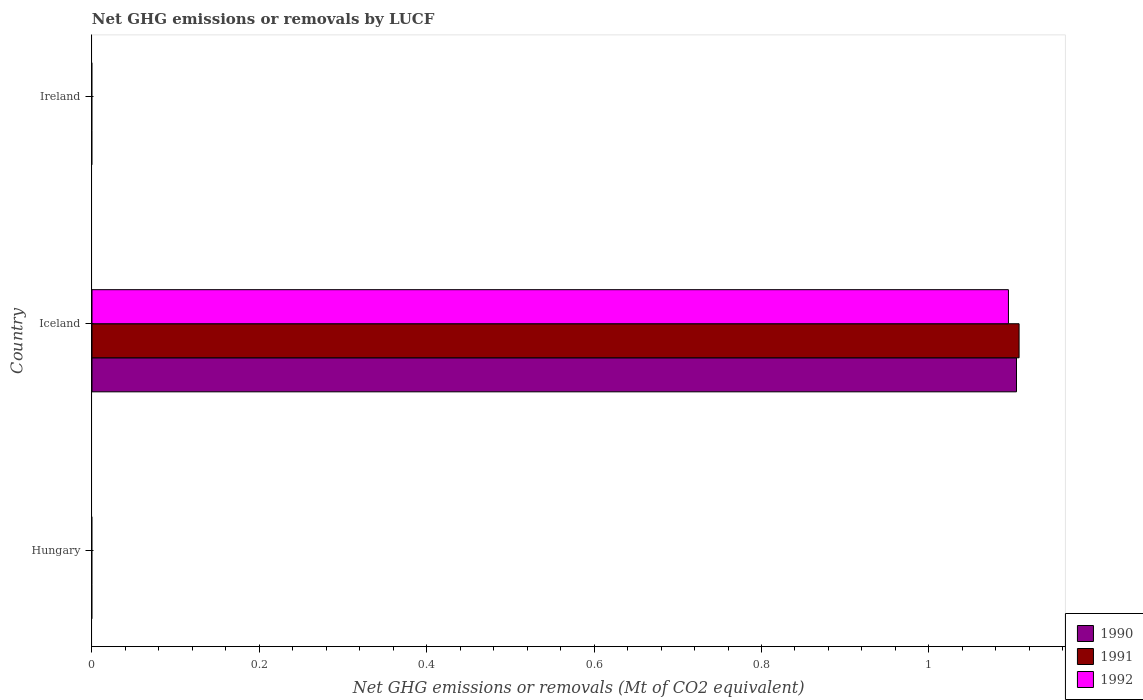How many different coloured bars are there?
Offer a terse response. 3. Are the number of bars per tick equal to the number of legend labels?
Offer a terse response. No. How many bars are there on the 3rd tick from the top?
Your response must be concise. 0. What is the label of the 2nd group of bars from the top?
Your response must be concise. Iceland. What is the net GHG emissions or removals by LUCF in 1991 in Iceland?
Your response must be concise. 1.11. Across all countries, what is the maximum net GHG emissions or removals by LUCF in 1990?
Your response must be concise. 1.1. Across all countries, what is the minimum net GHG emissions or removals by LUCF in 1992?
Your answer should be very brief. 0. In which country was the net GHG emissions or removals by LUCF in 1990 maximum?
Give a very brief answer. Iceland. What is the total net GHG emissions or removals by LUCF in 1990 in the graph?
Make the answer very short. 1.1. What is the average net GHG emissions or removals by LUCF in 1991 per country?
Give a very brief answer. 0.37. What is the difference between the net GHG emissions or removals by LUCF in 1992 and net GHG emissions or removals by LUCF in 1991 in Iceland?
Give a very brief answer. -0.01. What is the difference between the highest and the lowest net GHG emissions or removals by LUCF in 1991?
Provide a succinct answer. 1.11. Does the graph contain grids?
Provide a short and direct response. No. How many legend labels are there?
Offer a very short reply. 3. How are the legend labels stacked?
Your answer should be compact. Vertical. What is the title of the graph?
Provide a succinct answer. Net GHG emissions or removals by LUCF. Does "1970" appear as one of the legend labels in the graph?
Your answer should be very brief. No. What is the label or title of the X-axis?
Your response must be concise. Net GHG emissions or removals (Mt of CO2 equivalent). What is the Net GHG emissions or removals (Mt of CO2 equivalent) of 1990 in Hungary?
Ensure brevity in your answer.  0. What is the Net GHG emissions or removals (Mt of CO2 equivalent) in 1991 in Hungary?
Provide a short and direct response. 0. What is the Net GHG emissions or removals (Mt of CO2 equivalent) of 1990 in Iceland?
Give a very brief answer. 1.1. What is the Net GHG emissions or removals (Mt of CO2 equivalent) of 1991 in Iceland?
Your answer should be compact. 1.11. What is the Net GHG emissions or removals (Mt of CO2 equivalent) in 1992 in Iceland?
Your response must be concise. 1.1. What is the Net GHG emissions or removals (Mt of CO2 equivalent) in 1990 in Ireland?
Give a very brief answer. 0. Across all countries, what is the maximum Net GHG emissions or removals (Mt of CO2 equivalent) of 1990?
Provide a succinct answer. 1.1. Across all countries, what is the maximum Net GHG emissions or removals (Mt of CO2 equivalent) of 1991?
Your answer should be very brief. 1.11. Across all countries, what is the maximum Net GHG emissions or removals (Mt of CO2 equivalent) in 1992?
Offer a terse response. 1.1. Across all countries, what is the minimum Net GHG emissions or removals (Mt of CO2 equivalent) of 1990?
Provide a short and direct response. 0. Across all countries, what is the minimum Net GHG emissions or removals (Mt of CO2 equivalent) in 1991?
Offer a terse response. 0. What is the total Net GHG emissions or removals (Mt of CO2 equivalent) in 1990 in the graph?
Your answer should be compact. 1.1. What is the total Net GHG emissions or removals (Mt of CO2 equivalent) of 1991 in the graph?
Offer a terse response. 1.11. What is the total Net GHG emissions or removals (Mt of CO2 equivalent) of 1992 in the graph?
Provide a short and direct response. 1.1. What is the average Net GHG emissions or removals (Mt of CO2 equivalent) of 1990 per country?
Provide a short and direct response. 0.37. What is the average Net GHG emissions or removals (Mt of CO2 equivalent) in 1991 per country?
Your answer should be compact. 0.37. What is the average Net GHG emissions or removals (Mt of CO2 equivalent) in 1992 per country?
Offer a very short reply. 0.36. What is the difference between the Net GHG emissions or removals (Mt of CO2 equivalent) in 1990 and Net GHG emissions or removals (Mt of CO2 equivalent) in 1991 in Iceland?
Provide a succinct answer. -0. What is the difference between the Net GHG emissions or removals (Mt of CO2 equivalent) of 1990 and Net GHG emissions or removals (Mt of CO2 equivalent) of 1992 in Iceland?
Make the answer very short. 0.01. What is the difference between the Net GHG emissions or removals (Mt of CO2 equivalent) of 1991 and Net GHG emissions or removals (Mt of CO2 equivalent) of 1992 in Iceland?
Your answer should be very brief. 0.01. What is the difference between the highest and the lowest Net GHG emissions or removals (Mt of CO2 equivalent) of 1990?
Provide a succinct answer. 1.1. What is the difference between the highest and the lowest Net GHG emissions or removals (Mt of CO2 equivalent) in 1991?
Provide a succinct answer. 1.11. What is the difference between the highest and the lowest Net GHG emissions or removals (Mt of CO2 equivalent) of 1992?
Offer a very short reply. 1.1. 